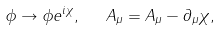Convert formula to latex. <formula><loc_0><loc_0><loc_500><loc_500>\phi \rightarrow \phi e ^ { i \chi } , \ \ A _ { \mu } = A _ { \mu } - \partial _ { \mu } \chi ,</formula> 